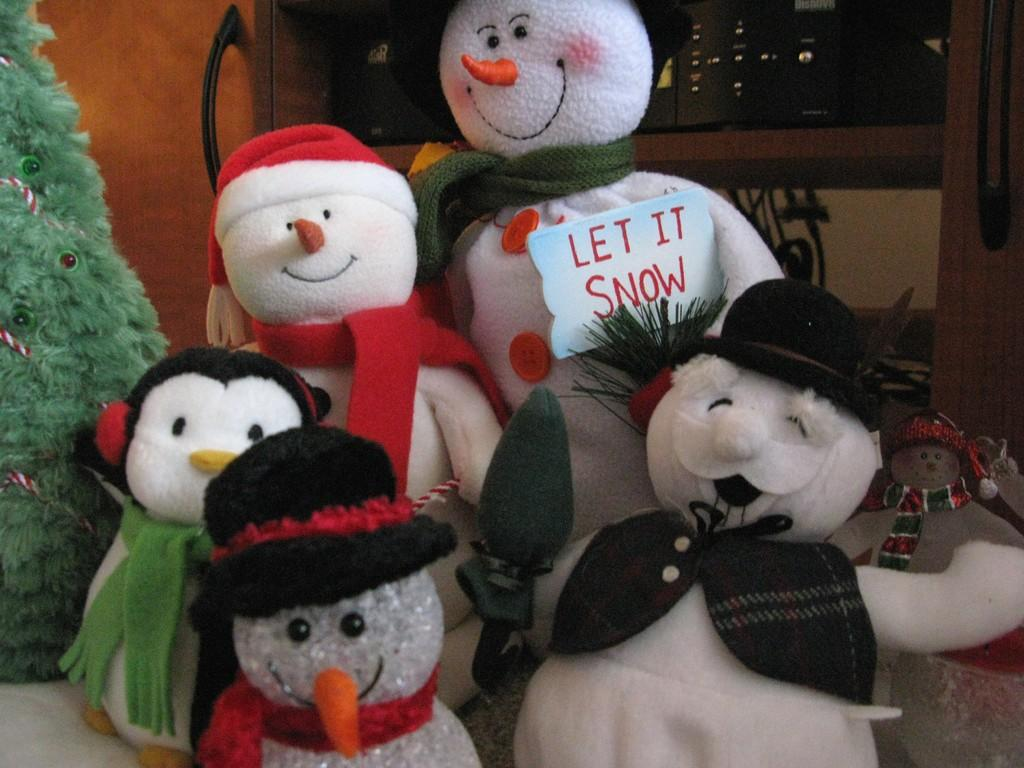What is the main subject of the image? The main subject of the image is a group of dolls. Where are the dolls placed in the image? The dolls are placed on a surface in the image. What can be seen in the background of the image? There is a tree and a door visible in the background of the image. What is written on the board in the image? There is a board with text in the image, but the specific text cannot be determined from the facts provided. What type of objects are in the shelf in the image? There are devices in a shelf in the image, but the specific devices cannot be determined from the facts provided. What type of knowledge can be gained from the band playing in the image? There is no band playing in the image, so no knowledge can be gained from a band in this context. 